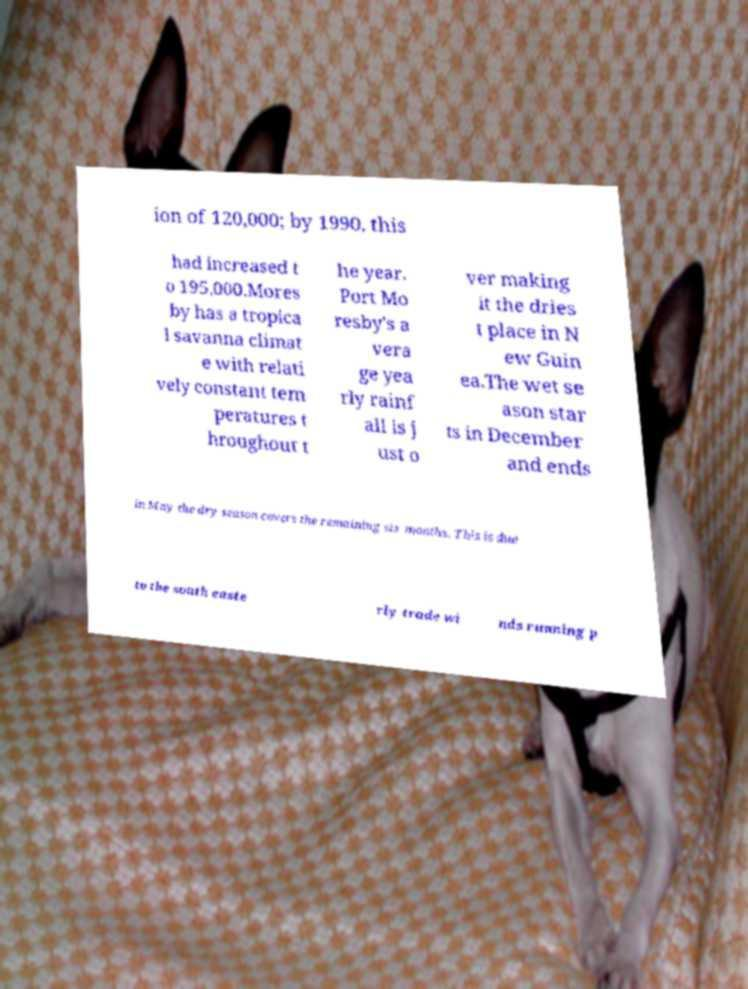Can you accurately transcribe the text from the provided image for me? ion of 120,000; by 1990, this had increased t o 195,000.Mores by has a tropica l savanna climat e with relati vely constant tem peratures t hroughout t he year. Port Mo resby's a vera ge yea rly rainf all is j ust o ver making it the dries t place in N ew Guin ea.The wet se ason star ts in December and ends in May the dry season covers the remaining six months. This is due to the south easte rly trade wi nds running p 